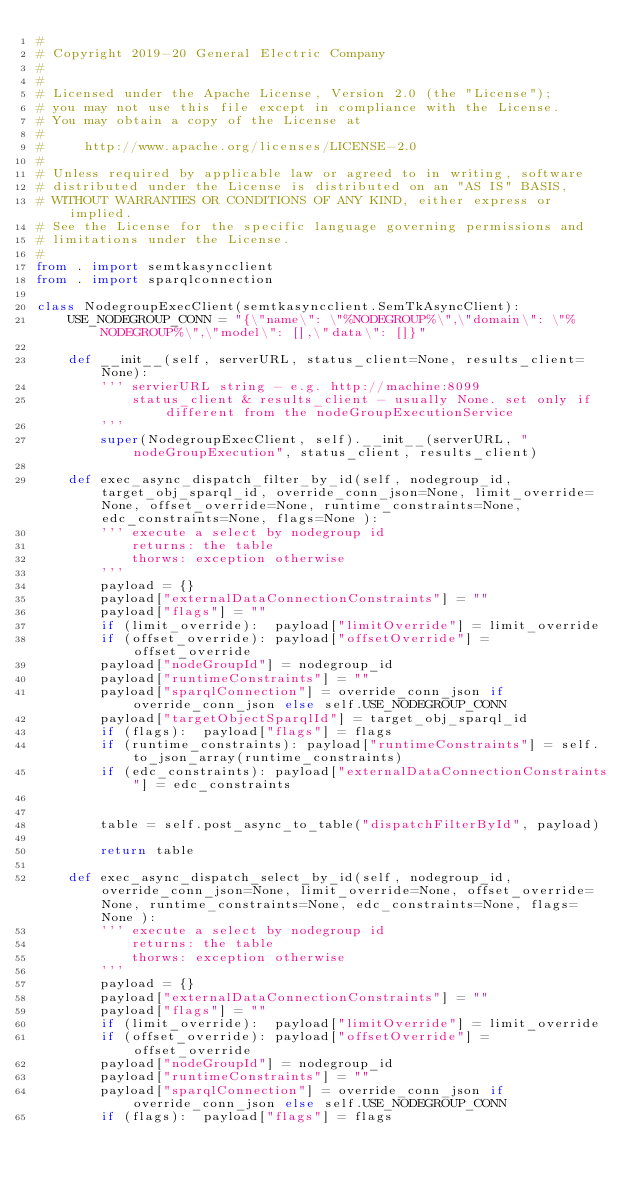Convert code to text. <code><loc_0><loc_0><loc_500><loc_500><_Python_>#
# Copyright 2019-20 General Electric Company
#
#
# Licensed under the Apache License, Version 2.0 (the "License");
# you may not use this file except in compliance with the License.
# You may obtain a copy of the License at
# 
#     http://www.apache.org/licenses/LICENSE-2.0
# 
# Unless required by applicable law or agreed to in writing, software
# distributed under the License is distributed on an "AS IS" BASIS,
# WITHOUT WARRANTIES OR CONDITIONS OF ANY KIND, either express or implied.
# See the License for the specific language governing permissions and
# limitations under the License.
#
from . import semtkasyncclient
from . import sparqlconnection

class NodegroupExecClient(semtkasyncclient.SemTkAsyncClient):
    USE_NODEGROUP_CONN = "{\"name\": \"%NODEGROUP%\",\"domain\": \"%NODEGROUP%\",\"model\": [],\"data\": []}"
    
    def __init__(self, serverURL, status_client=None, results_client=None):
        ''' servierURL string - e.g. http://machine:8099
            status_client & results_client - usually None. set only if different from the nodeGroupExecutionService
        '''
        super(NodegroupExecClient, self).__init__(serverURL, "nodeGroupExecution", status_client, results_client)
    
    def exec_async_dispatch_filter_by_id(self, nodegroup_id, target_obj_sparql_id, override_conn_json=None, limit_override=None, offset_override=None, runtime_constraints=None, edc_constraints=None, flags=None ):
        ''' execute a select by nodegroup id
            returns: the table
            thorws: exception otherwise
        '''
        payload = {}
        payload["externalDataConnectionConstraints"] = ""
        payload["flags"] = ""
        if (limit_override):  payload["limitOverride"] = limit_override
        if (offset_override): payload["offsetOverride"] = offset_override
        payload["nodeGroupId"] = nodegroup_id
        payload["runtimeConstraints"] = ""
        payload["sparqlConnection"] = override_conn_json if override_conn_json else self.USE_NODEGROUP_CONN
        payload["targetObjectSparqlId"] = target_obj_sparql_id
        if (flags):  payload["flags"] = flags
        if (runtime_constraints): payload["runtimeConstraints"] = self.to_json_array(runtime_constraints)
        if (edc_constraints): payload["externalDataConnectionConstraints"] = edc_constraints
        

        table = self.post_async_to_table("dispatchFilterById", payload)
        
        return table
    
    def exec_async_dispatch_select_by_id(self, nodegroup_id, override_conn_json=None, limit_override=None, offset_override=None, runtime_constraints=None, edc_constraints=None, flags=None ):
        ''' execute a select by nodegroup id
            returns: the table
            thorws: exception otherwise
        '''
        payload = {}
        payload["externalDataConnectionConstraints"] = ""
        payload["flags"] = ""
        if (limit_override):  payload["limitOverride"] = limit_override
        if (offset_override): payload["offsetOverride"] = offset_override
        payload["nodeGroupId"] = nodegroup_id
        payload["runtimeConstraints"] = ""
        payload["sparqlConnection"] = override_conn_json if override_conn_json else self.USE_NODEGROUP_CONN
        if (flags):  payload["flags"] = flags</code> 